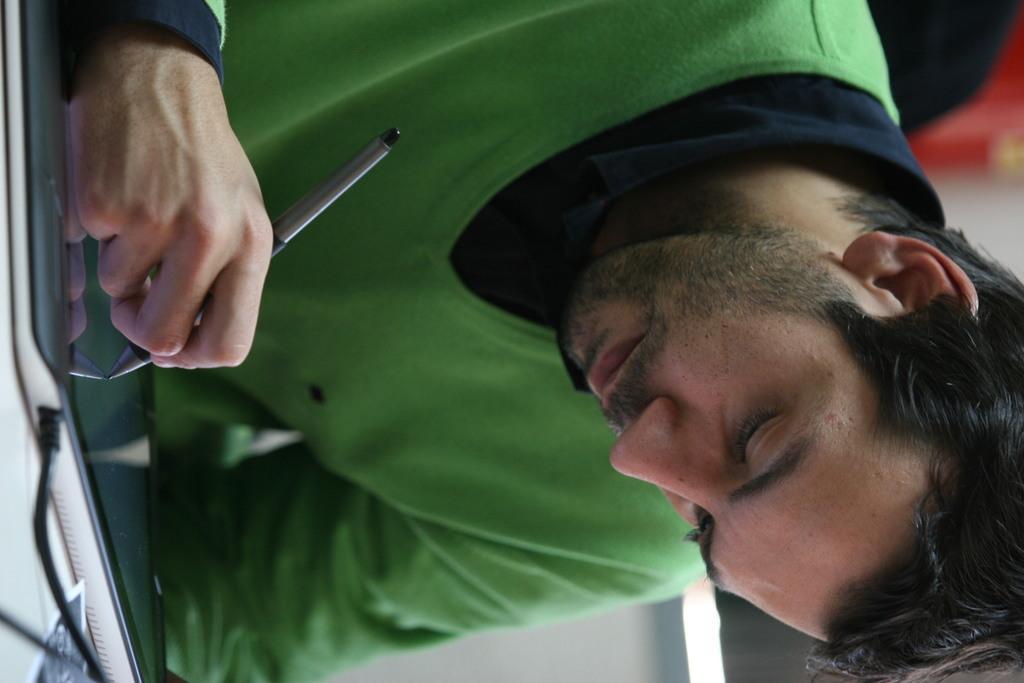Describe this image in one or two sentences. In this image there is a man sitting, he is holding an object, there is a device towards the left of the image, there is a wire towards the bottom of the image, there is an object towards the bottom of the image, there is an object towards the top of the image. 